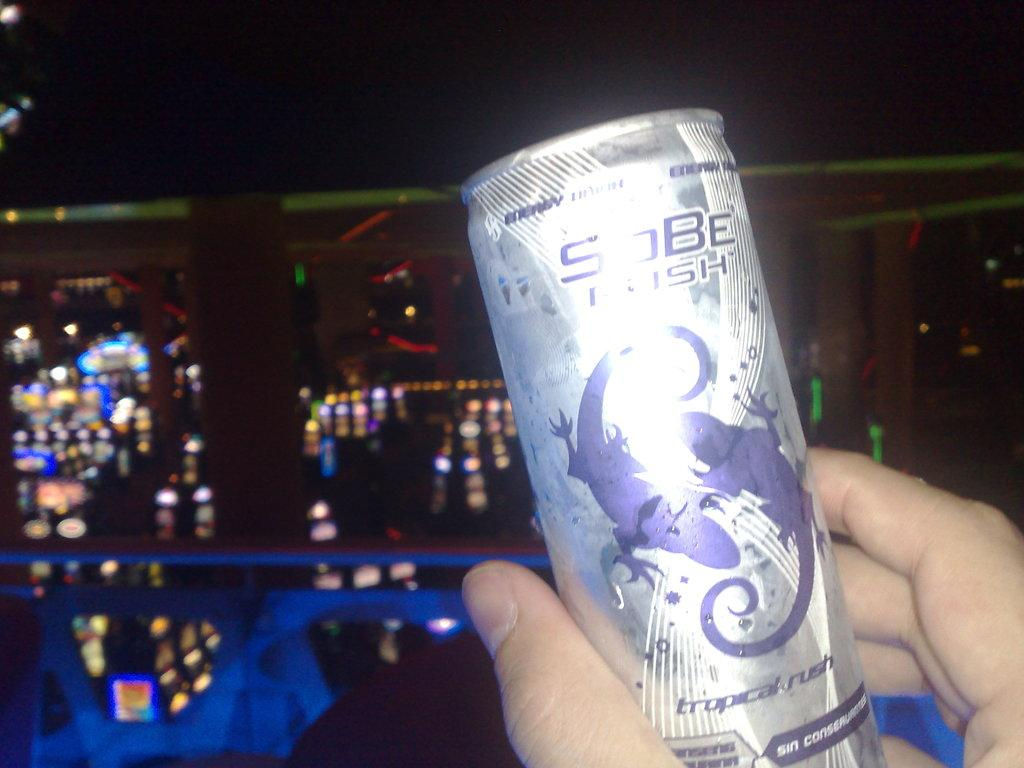Provide a one-sentence caption for the provided image. A Sobe energy drink is being held up in someone's hand. 